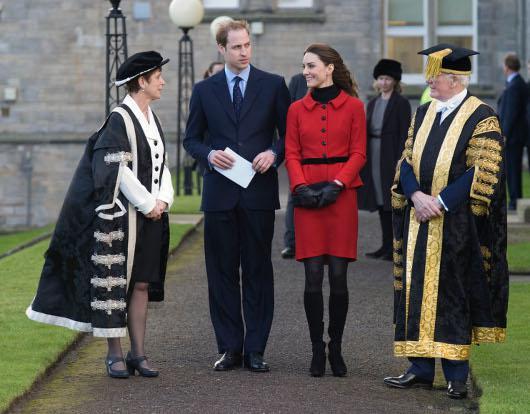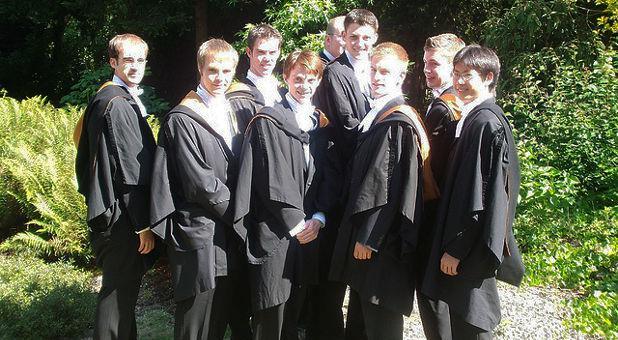The first image is the image on the left, the second image is the image on the right. Considering the images on both sides, is "At least four people hold red tube shapes and wear black robes in the foreground of one image." valid? Answer yes or no. No. The first image is the image on the left, the second image is the image on the right. Given the left and right images, does the statement "At least four graduates are holding red diploma tubes." hold true? Answer yes or no. No. 